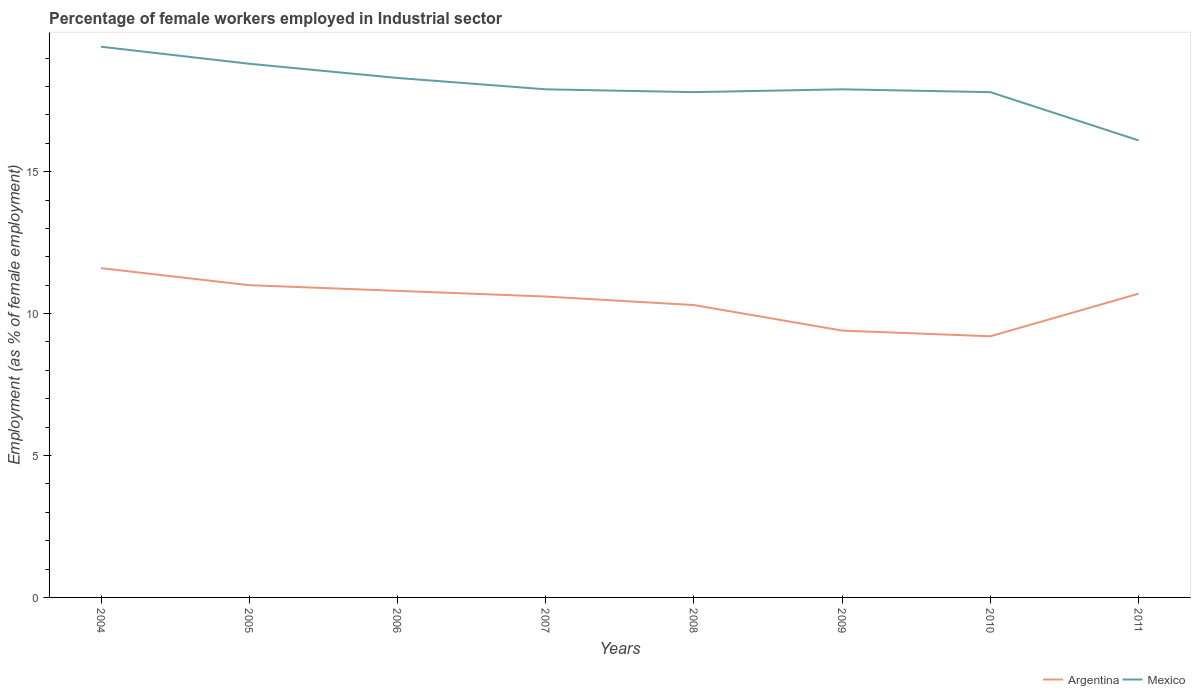How many different coloured lines are there?
Your answer should be compact. 2. Is the number of lines equal to the number of legend labels?
Make the answer very short. Yes. Across all years, what is the maximum percentage of females employed in Industrial sector in Argentina?
Provide a short and direct response. 9.2. In which year was the percentage of females employed in Industrial sector in Mexico maximum?
Make the answer very short. 2011. What is the total percentage of females employed in Industrial sector in Argentina in the graph?
Offer a very short reply. 1.3. What is the difference between the highest and the second highest percentage of females employed in Industrial sector in Mexico?
Your response must be concise. 3.3. Are the values on the major ticks of Y-axis written in scientific E-notation?
Offer a terse response. No. Does the graph contain grids?
Ensure brevity in your answer.  No. How are the legend labels stacked?
Your answer should be very brief. Horizontal. What is the title of the graph?
Provide a short and direct response. Percentage of female workers employed in Industrial sector. What is the label or title of the Y-axis?
Your response must be concise. Employment (as % of female employment). What is the Employment (as % of female employment) of Argentina in 2004?
Offer a terse response. 11.6. What is the Employment (as % of female employment) of Mexico in 2004?
Offer a very short reply. 19.4. What is the Employment (as % of female employment) of Argentina in 2005?
Provide a short and direct response. 11. What is the Employment (as % of female employment) in Mexico in 2005?
Your response must be concise. 18.8. What is the Employment (as % of female employment) in Argentina in 2006?
Offer a terse response. 10.8. What is the Employment (as % of female employment) of Mexico in 2006?
Ensure brevity in your answer.  18.3. What is the Employment (as % of female employment) in Argentina in 2007?
Provide a succinct answer. 10.6. What is the Employment (as % of female employment) of Mexico in 2007?
Ensure brevity in your answer.  17.9. What is the Employment (as % of female employment) of Argentina in 2008?
Offer a terse response. 10.3. What is the Employment (as % of female employment) in Mexico in 2008?
Your response must be concise. 17.8. What is the Employment (as % of female employment) in Argentina in 2009?
Your response must be concise. 9.4. What is the Employment (as % of female employment) of Mexico in 2009?
Offer a very short reply. 17.9. What is the Employment (as % of female employment) of Argentina in 2010?
Offer a very short reply. 9.2. What is the Employment (as % of female employment) in Mexico in 2010?
Your answer should be very brief. 17.8. What is the Employment (as % of female employment) in Argentina in 2011?
Your answer should be very brief. 10.7. What is the Employment (as % of female employment) of Mexico in 2011?
Your answer should be compact. 16.1. Across all years, what is the maximum Employment (as % of female employment) in Argentina?
Ensure brevity in your answer.  11.6. Across all years, what is the maximum Employment (as % of female employment) in Mexico?
Provide a succinct answer. 19.4. Across all years, what is the minimum Employment (as % of female employment) in Argentina?
Give a very brief answer. 9.2. Across all years, what is the minimum Employment (as % of female employment) of Mexico?
Make the answer very short. 16.1. What is the total Employment (as % of female employment) of Argentina in the graph?
Offer a terse response. 83.6. What is the total Employment (as % of female employment) in Mexico in the graph?
Ensure brevity in your answer.  144. What is the difference between the Employment (as % of female employment) in Mexico in 2004 and that in 2005?
Provide a short and direct response. 0.6. What is the difference between the Employment (as % of female employment) of Argentina in 2004 and that in 2006?
Your answer should be very brief. 0.8. What is the difference between the Employment (as % of female employment) in Argentina in 2004 and that in 2008?
Your response must be concise. 1.3. What is the difference between the Employment (as % of female employment) of Mexico in 2004 and that in 2009?
Ensure brevity in your answer.  1.5. What is the difference between the Employment (as % of female employment) of Argentina in 2004 and that in 2010?
Keep it short and to the point. 2.4. What is the difference between the Employment (as % of female employment) of Mexico in 2004 and that in 2010?
Your response must be concise. 1.6. What is the difference between the Employment (as % of female employment) in Mexico in 2004 and that in 2011?
Give a very brief answer. 3.3. What is the difference between the Employment (as % of female employment) of Argentina in 2005 and that in 2006?
Make the answer very short. 0.2. What is the difference between the Employment (as % of female employment) in Mexico in 2005 and that in 2006?
Keep it short and to the point. 0.5. What is the difference between the Employment (as % of female employment) in Argentina in 2006 and that in 2007?
Offer a terse response. 0.2. What is the difference between the Employment (as % of female employment) of Argentina in 2006 and that in 2008?
Provide a short and direct response. 0.5. What is the difference between the Employment (as % of female employment) of Mexico in 2006 and that in 2008?
Provide a succinct answer. 0.5. What is the difference between the Employment (as % of female employment) in Argentina in 2006 and that in 2009?
Make the answer very short. 1.4. What is the difference between the Employment (as % of female employment) in Mexico in 2006 and that in 2010?
Offer a very short reply. 0.5. What is the difference between the Employment (as % of female employment) in Mexico in 2007 and that in 2008?
Ensure brevity in your answer.  0.1. What is the difference between the Employment (as % of female employment) in Argentina in 2007 and that in 2009?
Give a very brief answer. 1.2. What is the difference between the Employment (as % of female employment) of Mexico in 2007 and that in 2009?
Make the answer very short. 0. What is the difference between the Employment (as % of female employment) of Mexico in 2007 and that in 2011?
Ensure brevity in your answer.  1.8. What is the difference between the Employment (as % of female employment) in Argentina in 2008 and that in 2010?
Keep it short and to the point. 1.1. What is the difference between the Employment (as % of female employment) in Mexico in 2008 and that in 2010?
Provide a succinct answer. 0. What is the difference between the Employment (as % of female employment) in Argentina in 2008 and that in 2011?
Keep it short and to the point. -0.4. What is the difference between the Employment (as % of female employment) of Mexico in 2008 and that in 2011?
Give a very brief answer. 1.7. What is the difference between the Employment (as % of female employment) in Argentina in 2009 and that in 2011?
Ensure brevity in your answer.  -1.3. What is the difference between the Employment (as % of female employment) of Argentina in 2010 and that in 2011?
Give a very brief answer. -1.5. What is the difference between the Employment (as % of female employment) of Mexico in 2010 and that in 2011?
Keep it short and to the point. 1.7. What is the difference between the Employment (as % of female employment) of Argentina in 2004 and the Employment (as % of female employment) of Mexico in 2006?
Your response must be concise. -6.7. What is the difference between the Employment (as % of female employment) in Argentina in 2004 and the Employment (as % of female employment) in Mexico in 2010?
Provide a short and direct response. -6.2. What is the difference between the Employment (as % of female employment) in Argentina in 2004 and the Employment (as % of female employment) in Mexico in 2011?
Provide a short and direct response. -4.5. What is the difference between the Employment (as % of female employment) in Argentina in 2005 and the Employment (as % of female employment) in Mexico in 2006?
Your answer should be very brief. -7.3. What is the difference between the Employment (as % of female employment) in Argentina in 2005 and the Employment (as % of female employment) in Mexico in 2008?
Your answer should be very brief. -6.8. What is the difference between the Employment (as % of female employment) of Argentina in 2005 and the Employment (as % of female employment) of Mexico in 2009?
Make the answer very short. -6.9. What is the difference between the Employment (as % of female employment) in Argentina in 2006 and the Employment (as % of female employment) in Mexico in 2008?
Give a very brief answer. -7. What is the difference between the Employment (as % of female employment) of Argentina in 2006 and the Employment (as % of female employment) of Mexico in 2009?
Your answer should be very brief. -7.1. What is the difference between the Employment (as % of female employment) in Argentina in 2007 and the Employment (as % of female employment) in Mexico in 2008?
Keep it short and to the point. -7.2. What is the difference between the Employment (as % of female employment) of Argentina in 2007 and the Employment (as % of female employment) of Mexico in 2010?
Provide a short and direct response. -7.2. What is the difference between the Employment (as % of female employment) in Argentina in 2008 and the Employment (as % of female employment) in Mexico in 2009?
Offer a very short reply. -7.6. What is the difference between the Employment (as % of female employment) in Argentina in 2010 and the Employment (as % of female employment) in Mexico in 2011?
Your response must be concise. -6.9. What is the average Employment (as % of female employment) of Argentina per year?
Give a very brief answer. 10.45. What is the average Employment (as % of female employment) in Mexico per year?
Your answer should be very brief. 18. In the year 2006, what is the difference between the Employment (as % of female employment) in Argentina and Employment (as % of female employment) in Mexico?
Provide a short and direct response. -7.5. In the year 2008, what is the difference between the Employment (as % of female employment) in Argentina and Employment (as % of female employment) in Mexico?
Your answer should be very brief. -7.5. In the year 2009, what is the difference between the Employment (as % of female employment) in Argentina and Employment (as % of female employment) in Mexico?
Provide a short and direct response. -8.5. In the year 2010, what is the difference between the Employment (as % of female employment) in Argentina and Employment (as % of female employment) in Mexico?
Make the answer very short. -8.6. What is the ratio of the Employment (as % of female employment) in Argentina in 2004 to that in 2005?
Your answer should be compact. 1.05. What is the ratio of the Employment (as % of female employment) of Mexico in 2004 to that in 2005?
Your answer should be very brief. 1.03. What is the ratio of the Employment (as % of female employment) of Argentina in 2004 to that in 2006?
Provide a succinct answer. 1.07. What is the ratio of the Employment (as % of female employment) of Mexico in 2004 to that in 2006?
Provide a short and direct response. 1.06. What is the ratio of the Employment (as % of female employment) of Argentina in 2004 to that in 2007?
Provide a succinct answer. 1.09. What is the ratio of the Employment (as % of female employment) of Mexico in 2004 to that in 2007?
Provide a succinct answer. 1.08. What is the ratio of the Employment (as % of female employment) in Argentina in 2004 to that in 2008?
Offer a terse response. 1.13. What is the ratio of the Employment (as % of female employment) in Mexico in 2004 to that in 2008?
Give a very brief answer. 1.09. What is the ratio of the Employment (as % of female employment) in Argentina in 2004 to that in 2009?
Provide a succinct answer. 1.23. What is the ratio of the Employment (as % of female employment) in Mexico in 2004 to that in 2009?
Ensure brevity in your answer.  1.08. What is the ratio of the Employment (as % of female employment) of Argentina in 2004 to that in 2010?
Offer a very short reply. 1.26. What is the ratio of the Employment (as % of female employment) of Mexico in 2004 to that in 2010?
Your answer should be very brief. 1.09. What is the ratio of the Employment (as % of female employment) in Argentina in 2004 to that in 2011?
Your answer should be very brief. 1.08. What is the ratio of the Employment (as % of female employment) in Mexico in 2004 to that in 2011?
Make the answer very short. 1.21. What is the ratio of the Employment (as % of female employment) of Argentina in 2005 to that in 2006?
Keep it short and to the point. 1.02. What is the ratio of the Employment (as % of female employment) in Mexico in 2005 to that in 2006?
Your response must be concise. 1.03. What is the ratio of the Employment (as % of female employment) of Argentina in 2005 to that in 2007?
Ensure brevity in your answer.  1.04. What is the ratio of the Employment (as % of female employment) in Mexico in 2005 to that in 2007?
Your response must be concise. 1.05. What is the ratio of the Employment (as % of female employment) of Argentina in 2005 to that in 2008?
Give a very brief answer. 1.07. What is the ratio of the Employment (as % of female employment) of Mexico in 2005 to that in 2008?
Ensure brevity in your answer.  1.06. What is the ratio of the Employment (as % of female employment) of Argentina in 2005 to that in 2009?
Provide a short and direct response. 1.17. What is the ratio of the Employment (as % of female employment) of Mexico in 2005 to that in 2009?
Ensure brevity in your answer.  1.05. What is the ratio of the Employment (as % of female employment) in Argentina in 2005 to that in 2010?
Your answer should be very brief. 1.2. What is the ratio of the Employment (as % of female employment) in Mexico in 2005 to that in 2010?
Your answer should be very brief. 1.06. What is the ratio of the Employment (as % of female employment) of Argentina in 2005 to that in 2011?
Provide a short and direct response. 1.03. What is the ratio of the Employment (as % of female employment) in Mexico in 2005 to that in 2011?
Your answer should be compact. 1.17. What is the ratio of the Employment (as % of female employment) of Argentina in 2006 to that in 2007?
Make the answer very short. 1.02. What is the ratio of the Employment (as % of female employment) of Mexico in 2006 to that in 2007?
Your response must be concise. 1.02. What is the ratio of the Employment (as % of female employment) of Argentina in 2006 to that in 2008?
Give a very brief answer. 1.05. What is the ratio of the Employment (as % of female employment) of Mexico in 2006 to that in 2008?
Make the answer very short. 1.03. What is the ratio of the Employment (as % of female employment) in Argentina in 2006 to that in 2009?
Your response must be concise. 1.15. What is the ratio of the Employment (as % of female employment) in Mexico in 2006 to that in 2009?
Your answer should be compact. 1.02. What is the ratio of the Employment (as % of female employment) of Argentina in 2006 to that in 2010?
Your answer should be compact. 1.17. What is the ratio of the Employment (as % of female employment) of Mexico in 2006 to that in 2010?
Keep it short and to the point. 1.03. What is the ratio of the Employment (as % of female employment) in Argentina in 2006 to that in 2011?
Offer a very short reply. 1.01. What is the ratio of the Employment (as % of female employment) of Mexico in 2006 to that in 2011?
Provide a short and direct response. 1.14. What is the ratio of the Employment (as % of female employment) of Argentina in 2007 to that in 2008?
Ensure brevity in your answer.  1.03. What is the ratio of the Employment (as % of female employment) in Mexico in 2007 to that in 2008?
Offer a terse response. 1.01. What is the ratio of the Employment (as % of female employment) in Argentina in 2007 to that in 2009?
Your answer should be compact. 1.13. What is the ratio of the Employment (as % of female employment) in Mexico in 2007 to that in 2009?
Your response must be concise. 1. What is the ratio of the Employment (as % of female employment) of Argentina in 2007 to that in 2010?
Make the answer very short. 1.15. What is the ratio of the Employment (as % of female employment) in Mexico in 2007 to that in 2010?
Your answer should be compact. 1.01. What is the ratio of the Employment (as % of female employment) of Mexico in 2007 to that in 2011?
Offer a terse response. 1.11. What is the ratio of the Employment (as % of female employment) of Argentina in 2008 to that in 2009?
Provide a short and direct response. 1.1. What is the ratio of the Employment (as % of female employment) of Mexico in 2008 to that in 2009?
Your response must be concise. 0.99. What is the ratio of the Employment (as % of female employment) in Argentina in 2008 to that in 2010?
Your answer should be very brief. 1.12. What is the ratio of the Employment (as % of female employment) in Mexico in 2008 to that in 2010?
Offer a very short reply. 1. What is the ratio of the Employment (as % of female employment) in Argentina in 2008 to that in 2011?
Make the answer very short. 0.96. What is the ratio of the Employment (as % of female employment) of Mexico in 2008 to that in 2011?
Your answer should be compact. 1.11. What is the ratio of the Employment (as % of female employment) of Argentina in 2009 to that in 2010?
Keep it short and to the point. 1.02. What is the ratio of the Employment (as % of female employment) in Mexico in 2009 to that in 2010?
Your answer should be compact. 1.01. What is the ratio of the Employment (as % of female employment) in Argentina in 2009 to that in 2011?
Provide a succinct answer. 0.88. What is the ratio of the Employment (as % of female employment) in Mexico in 2009 to that in 2011?
Your answer should be very brief. 1.11. What is the ratio of the Employment (as % of female employment) in Argentina in 2010 to that in 2011?
Provide a succinct answer. 0.86. What is the ratio of the Employment (as % of female employment) in Mexico in 2010 to that in 2011?
Provide a succinct answer. 1.11. What is the difference between the highest and the second highest Employment (as % of female employment) in Mexico?
Ensure brevity in your answer.  0.6. What is the difference between the highest and the lowest Employment (as % of female employment) in Argentina?
Ensure brevity in your answer.  2.4. 